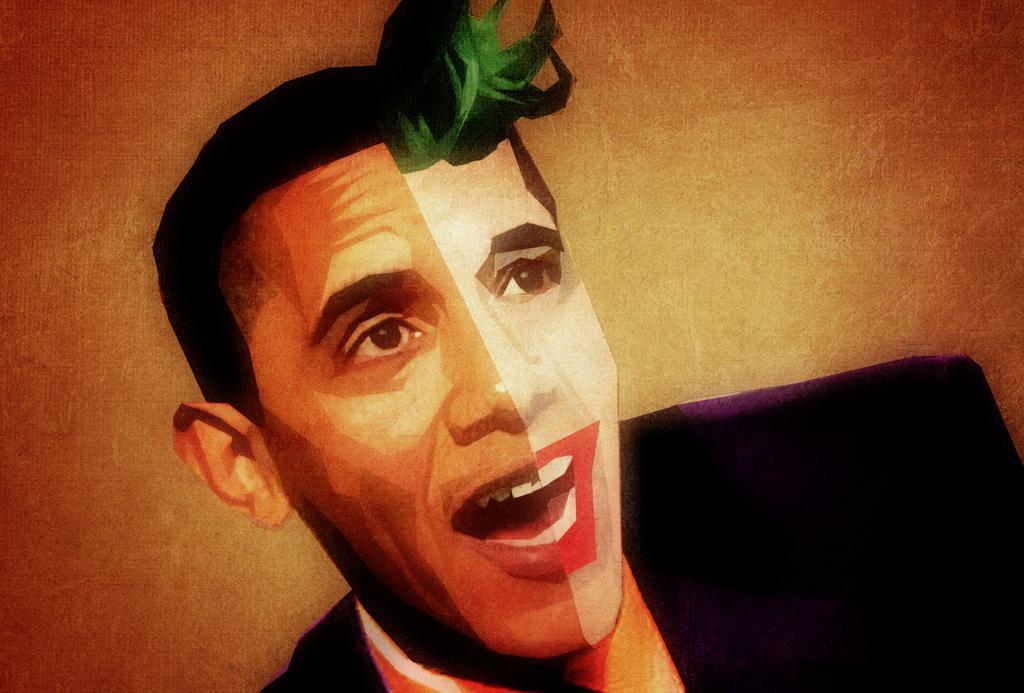Describe this image in one or two sentences. In this image, we can see a picture of a man wearing a black color shirt. In the background, we can see green color and an orange color. 